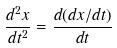<formula> <loc_0><loc_0><loc_500><loc_500>\frac { d ^ { 2 } x } { d t ^ { 2 } } = \frac { d ( d x / d t ) } { d t }</formula> 